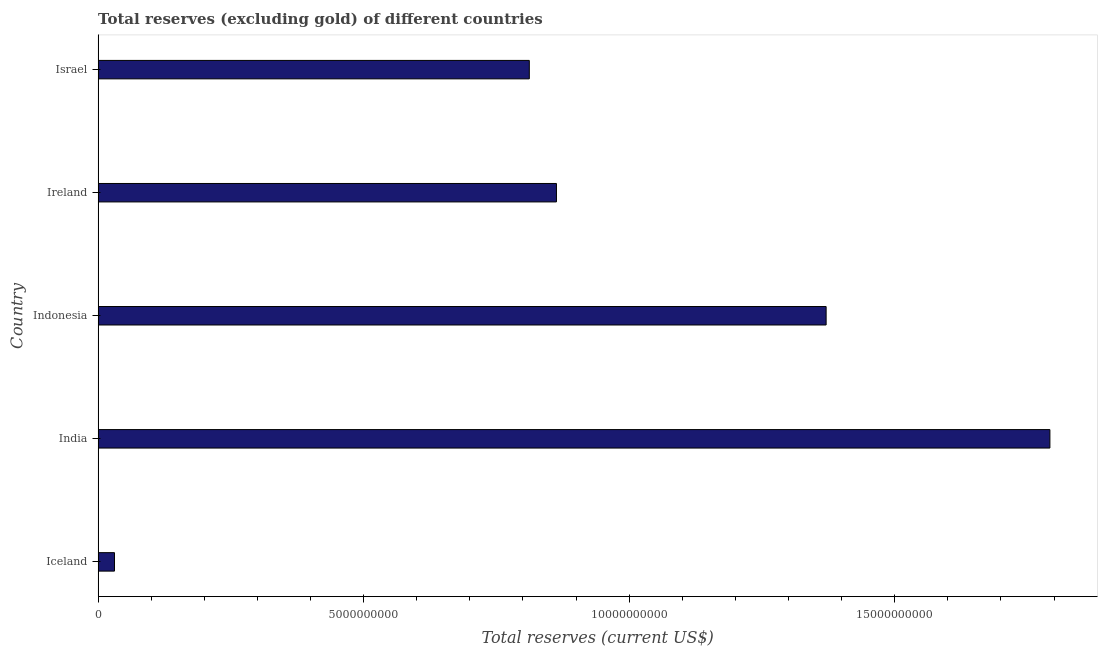Does the graph contain grids?
Your response must be concise. No. What is the title of the graph?
Offer a terse response. Total reserves (excluding gold) of different countries. What is the label or title of the X-axis?
Provide a succinct answer. Total reserves (current US$). What is the label or title of the Y-axis?
Give a very brief answer. Country. What is the total reserves (excluding gold) in India?
Ensure brevity in your answer.  1.79e+1. Across all countries, what is the maximum total reserves (excluding gold)?
Provide a short and direct response. 1.79e+1. Across all countries, what is the minimum total reserves (excluding gold)?
Your answer should be compact. 3.08e+08. What is the sum of the total reserves (excluding gold)?
Give a very brief answer. 4.87e+1. What is the difference between the total reserves (excluding gold) in India and Ireland?
Offer a very short reply. 9.29e+09. What is the average total reserves (excluding gold) per country?
Offer a very short reply. 9.74e+09. What is the median total reserves (excluding gold)?
Provide a succinct answer. 8.63e+09. In how many countries, is the total reserves (excluding gold) greater than 2000000000 US$?
Give a very brief answer. 4. What is the ratio of the total reserves (excluding gold) in Indonesia to that in Ireland?
Make the answer very short. 1.59. Is the total reserves (excluding gold) in Ireland less than that in Israel?
Give a very brief answer. No. Is the difference between the total reserves (excluding gold) in India and Israel greater than the difference between any two countries?
Make the answer very short. No. What is the difference between the highest and the second highest total reserves (excluding gold)?
Give a very brief answer. 4.21e+09. What is the difference between the highest and the lowest total reserves (excluding gold)?
Offer a terse response. 1.76e+1. How many bars are there?
Offer a terse response. 5. How many countries are there in the graph?
Offer a terse response. 5. What is the difference between two consecutive major ticks on the X-axis?
Provide a short and direct response. 5.00e+09. Are the values on the major ticks of X-axis written in scientific E-notation?
Provide a short and direct response. No. What is the Total reserves (current US$) in Iceland?
Ensure brevity in your answer.  3.08e+08. What is the Total reserves (current US$) in India?
Make the answer very short. 1.79e+1. What is the Total reserves (current US$) in Indonesia?
Make the answer very short. 1.37e+1. What is the Total reserves (current US$) in Ireland?
Provide a short and direct response. 8.63e+09. What is the Total reserves (current US$) of Israel?
Make the answer very short. 8.12e+09. What is the difference between the Total reserves (current US$) in Iceland and India?
Your answer should be very brief. -1.76e+1. What is the difference between the Total reserves (current US$) in Iceland and Indonesia?
Offer a very short reply. -1.34e+1. What is the difference between the Total reserves (current US$) in Iceland and Ireland?
Provide a short and direct response. -8.32e+09. What is the difference between the Total reserves (current US$) in Iceland and Israel?
Keep it short and to the point. -7.81e+09. What is the difference between the Total reserves (current US$) in India and Indonesia?
Offer a very short reply. 4.21e+09. What is the difference between the Total reserves (current US$) in India and Ireland?
Give a very brief answer. 9.29e+09. What is the difference between the Total reserves (current US$) in India and Israel?
Provide a short and direct response. 9.80e+09. What is the difference between the Total reserves (current US$) in Indonesia and Ireland?
Keep it short and to the point. 5.08e+09. What is the difference between the Total reserves (current US$) in Indonesia and Israel?
Make the answer very short. 5.59e+09. What is the difference between the Total reserves (current US$) in Ireland and Israel?
Ensure brevity in your answer.  5.11e+08. What is the ratio of the Total reserves (current US$) in Iceland to that in India?
Your answer should be very brief. 0.02. What is the ratio of the Total reserves (current US$) in Iceland to that in Indonesia?
Provide a succinct answer. 0.02. What is the ratio of the Total reserves (current US$) in Iceland to that in Ireland?
Provide a short and direct response. 0.04. What is the ratio of the Total reserves (current US$) in Iceland to that in Israel?
Provide a succinct answer. 0.04. What is the ratio of the Total reserves (current US$) in India to that in Indonesia?
Ensure brevity in your answer.  1.31. What is the ratio of the Total reserves (current US$) in India to that in Ireland?
Offer a terse response. 2.08. What is the ratio of the Total reserves (current US$) in India to that in Israel?
Make the answer very short. 2.21. What is the ratio of the Total reserves (current US$) in Indonesia to that in Ireland?
Make the answer very short. 1.59. What is the ratio of the Total reserves (current US$) in Indonesia to that in Israel?
Your response must be concise. 1.69. What is the ratio of the Total reserves (current US$) in Ireland to that in Israel?
Keep it short and to the point. 1.06. 